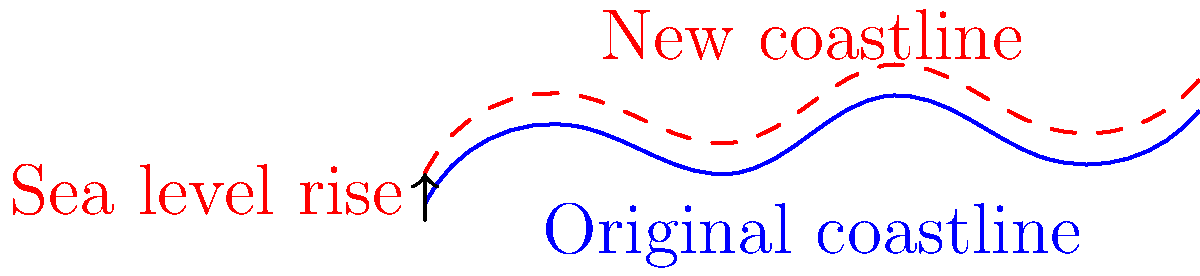As a science reporter interviewing a geoscientist about coastal changes due to sea level rise, you come across the diagram above. What topological change is most prominently illustrated in this representation of coastline transformation? To answer this question, let's analyze the diagram step-by-step:

1. The blue line represents the original coastline, while the red dashed line shows the new coastline after sea level rise.

2. Observe that the overall shape of the coastline remains similar, but the red line is shifted upward and slightly inland compared to the blue line.

3. This shift represents a change in the coastline's position due to sea level rise, as indicated by the arrow on the left side of the diagram.

4. The most notable topological change illustrated here is the reduction in the land area between the original and new coastlines. This area has been submerged due to the rising sea level.

5. In topological terms, this change can be described as a "transgression" of the sea onto the land, resulting in a landward migration of the shoreline.

6. The continuity of the coastline is maintained (i.e., there are no breaks or islands formed), but its position has changed relative to the land.

7. This type of change is particularly significant for low-lying coastal areas, as it can lead to the loss of beaches, coastal wetlands, and even inhabited areas.

The key topological change illustrated is therefore the landward migration of the shoreline, resulting in a reduction of land area and a corresponding increase in sea area.
Answer: Landward migration of the shoreline 